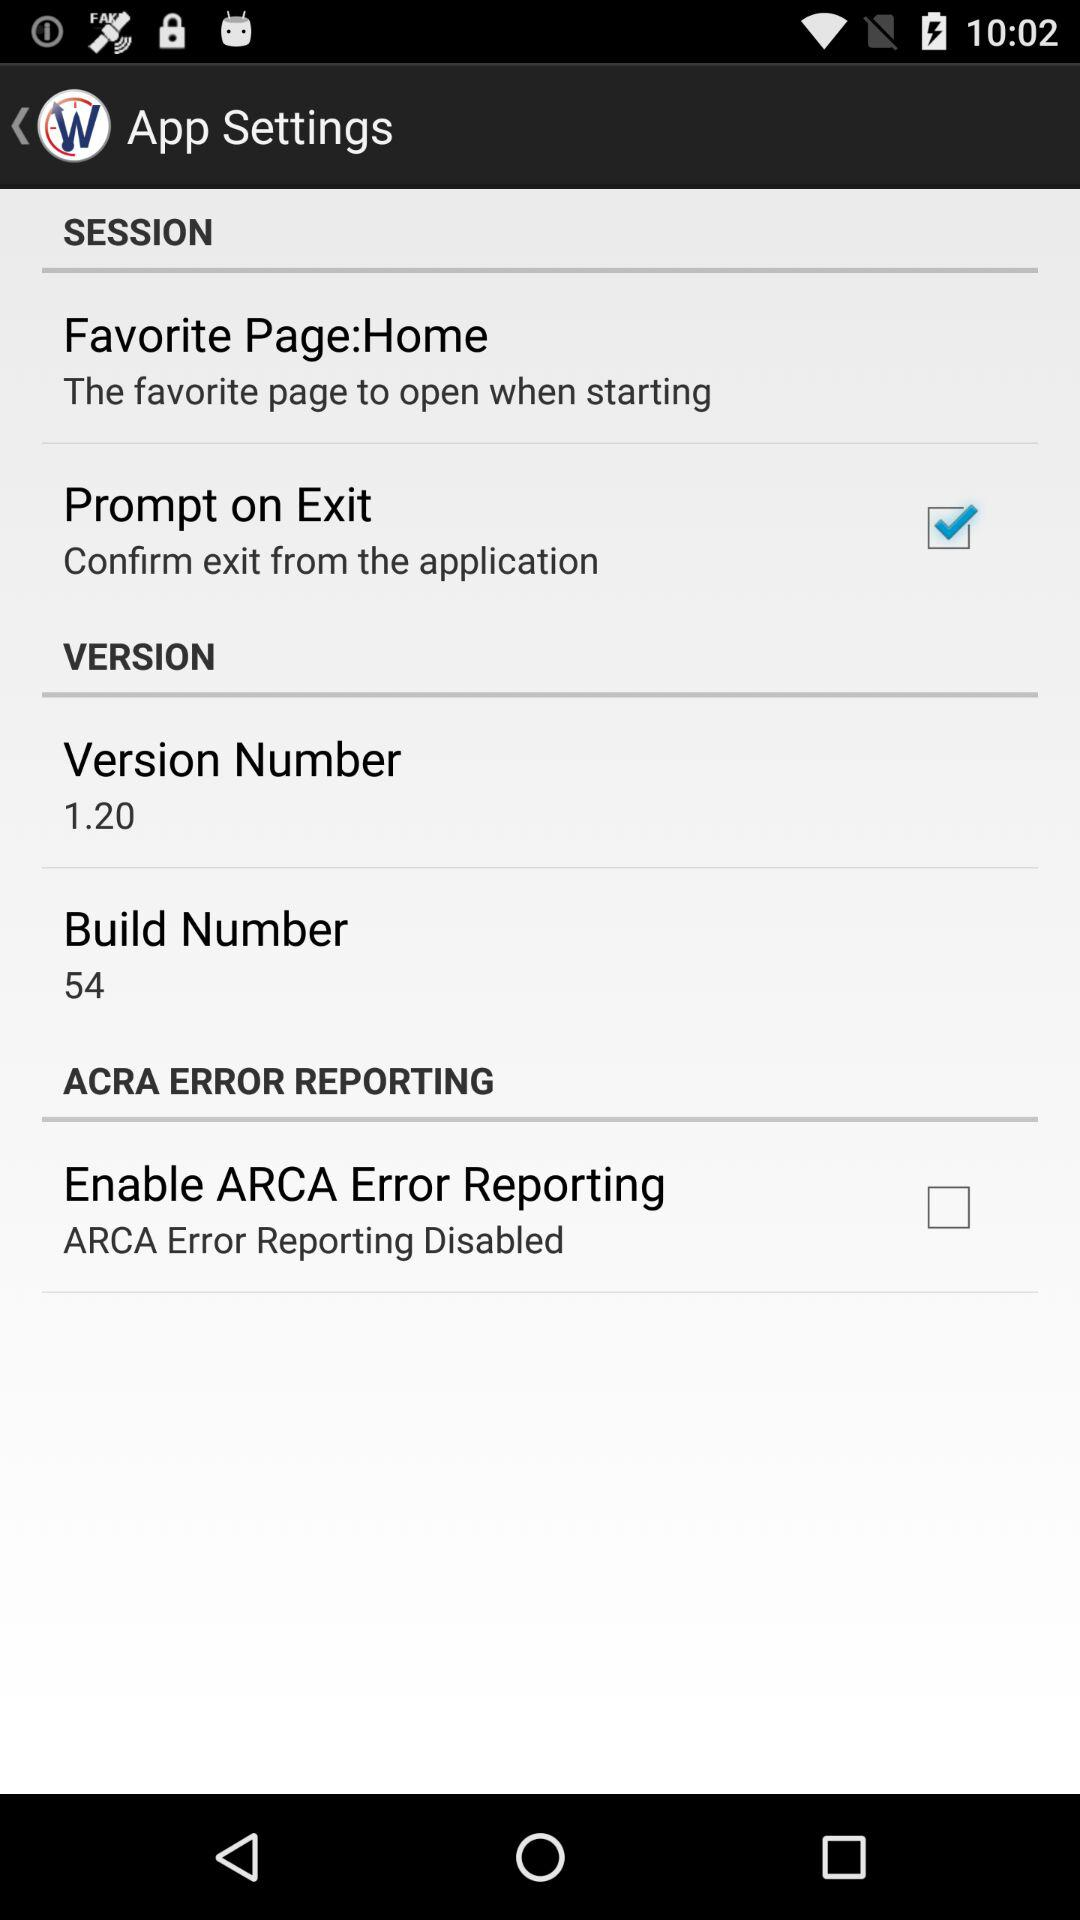What is the status of the "Enable ARCA Error Reporting" setting? The status of the "Enable ARCA Error Reporting" setting is "off". 